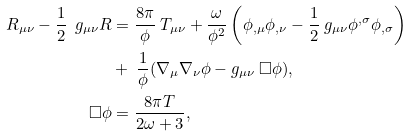Convert formula to latex. <formula><loc_0><loc_0><loc_500><loc_500>R _ { \mu \nu } - \frac { 1 } { 2 } \ g _ { \mu \nu } R & = \frac { 8 \pi } { \phi } \ T _ { \mu \nu } + \frac { \omega } { \phi ^ { 2 } } \left ( \phi _ { , \mu } \phi _ { , \nu } - \frac { 1 } { 2 } \ g _ { \mu \nu } \phi ^ { , \sigma } \phi _ { , \sigma } \right ) \\ & + \ \frac { 1 } { \phi } ( \nabla _ { \mu } \nabla _ { \nu } \phi - g _ { \mu \nu } \ \Box \phi ) , \\ \Box \phi & = \frac { 8 \pi T } { 2 \omega + 3 } ,</formula> 